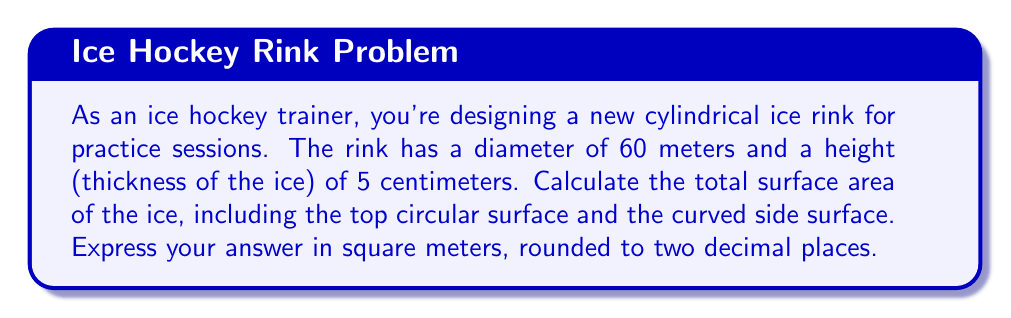Can you solve this math problem? To solve this problem, we need to calculate the surface area of a cylinder, which consists of two circular bases and the curved lateral surface. Let's break it down step-by-step:

1. Calculate the radius of the rink:
   $r = \frac{diameter}{2} = \frac{60\text{ m}}{2} = 30\text{ m}$

2. Calculate the height in meters:
   $h = 5\text{ cm} = 0.05\text{ m}$

3. Calculate the area of one circular base:
   $A_{base} = \pi r^2 = \pi (30\text{ m})^2 = 900\pi\text{ m}^2$

4. Calculate the area of the curved lateral surface:
   $A_{lateral} = 2\pi rh = 2\pi (30\text{ m})(0.05\text{ m}) = 3\pi\text{ m}^2$

5. Sum up the total surface area:
   $$\begin{align}
   A_{total} &= A_{base} + A_{lateral} \\
   &= 900\pi\text{ m}^2 + 3\pi\text{ m}^2 \\
   &= 903\pi\text{ m}^2
   \end{align}$$

6. Evaluate and round to two decimal places:
   $A_{total} = 903\pi\text{ m}^2 \approx 2,836.04\text{ m}^2$
Answer: 2,836.04 m² 